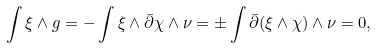Convert formula to latex. <formula><loc_0><loc_0><loc_500><loc_500>\int \xi \wedge g = - \int \xi \wedge \bar { \partial } \chi \wedge \nu = \pm \int \bar { \partial } ( \xi \wedge \chi ) \wedge \nu = 0 ,</formula> 